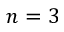<formula> <loc_0><loc_0><loc_500><loc_500>n = 3</formula> 